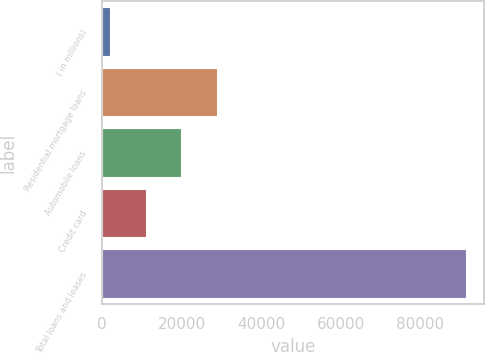Convert chart. <chart><loc_0><loc_0><loc_500><loc_500><bar_chart><fcel>( in millions)<fcel>Residential mortgage loans<fcel>Automobile loans<fcel>Credit card<fcel>Total loans and leases<nl><fcel>2014<fcel>28813.3<fcel>19880.2<fcel>10947.1<fcel>91345<nl></chart> 